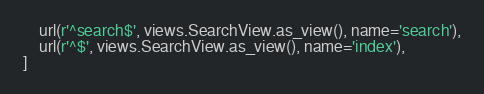Convert code to text. <code><loc_0><loc_0><loc_500><loc_500><_Python_>    url(r'^search$', views.SearchView.as_view(), name='search'),
    url(r'^$', views.SearchView.as_view(), name='index'),
]
</code> 